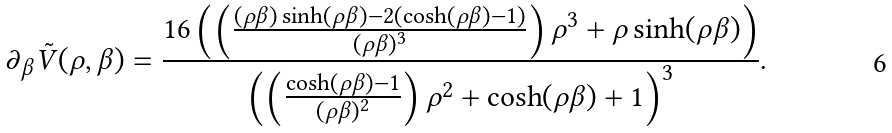<formula> <loc_0><loc_0><loc_500><loc_500>\partial _ { \beta } \tilde { V } ( \rho , \beta ) = \frac { 1 6 \left ( \left ( \frac { ( \rho \beta ) \sinh ( \rho \beta ) - 2 ( \cosh ( \rho \beta ) - 1 ) } { ( \rho \beta ) ^ { 3 } } \right ) \rho ^ { 3 } + \rho \sinh ( \rho \beta ) \right ) } { \left ( \left ( \frac { \cosh ( \rho \beta ) - 1 } { ( \rho \beta ) ^ { 2 } } \right ) \rho ^ { 2 } + \cosh ( \rho \beta ) + 1 \right ) ^ { 3 } } .</formula> 